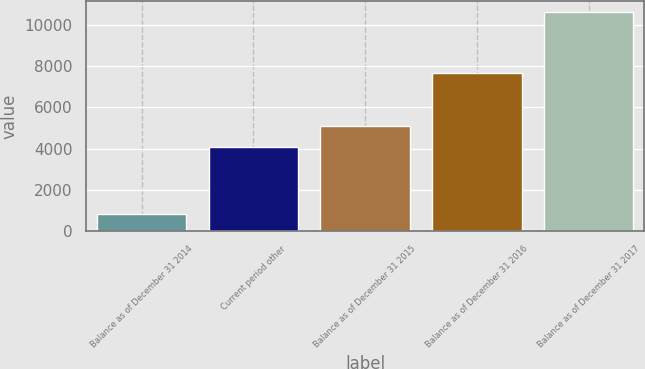Convert chart to OTSL. <chart><loc_0><loc_0><loc_500><loc_500><bar_chart><fcel>Balance as of December 31 2014<fcel>Current period other<fcel>Balance as of December 31 2015<fcel>Balance as of December 31 2016<fcel>Balance as of December 31 2017<nl><fcel>816<fcel>4100<fcel>5078.4<fcel>7673<fcel>10600<nl></chart> 